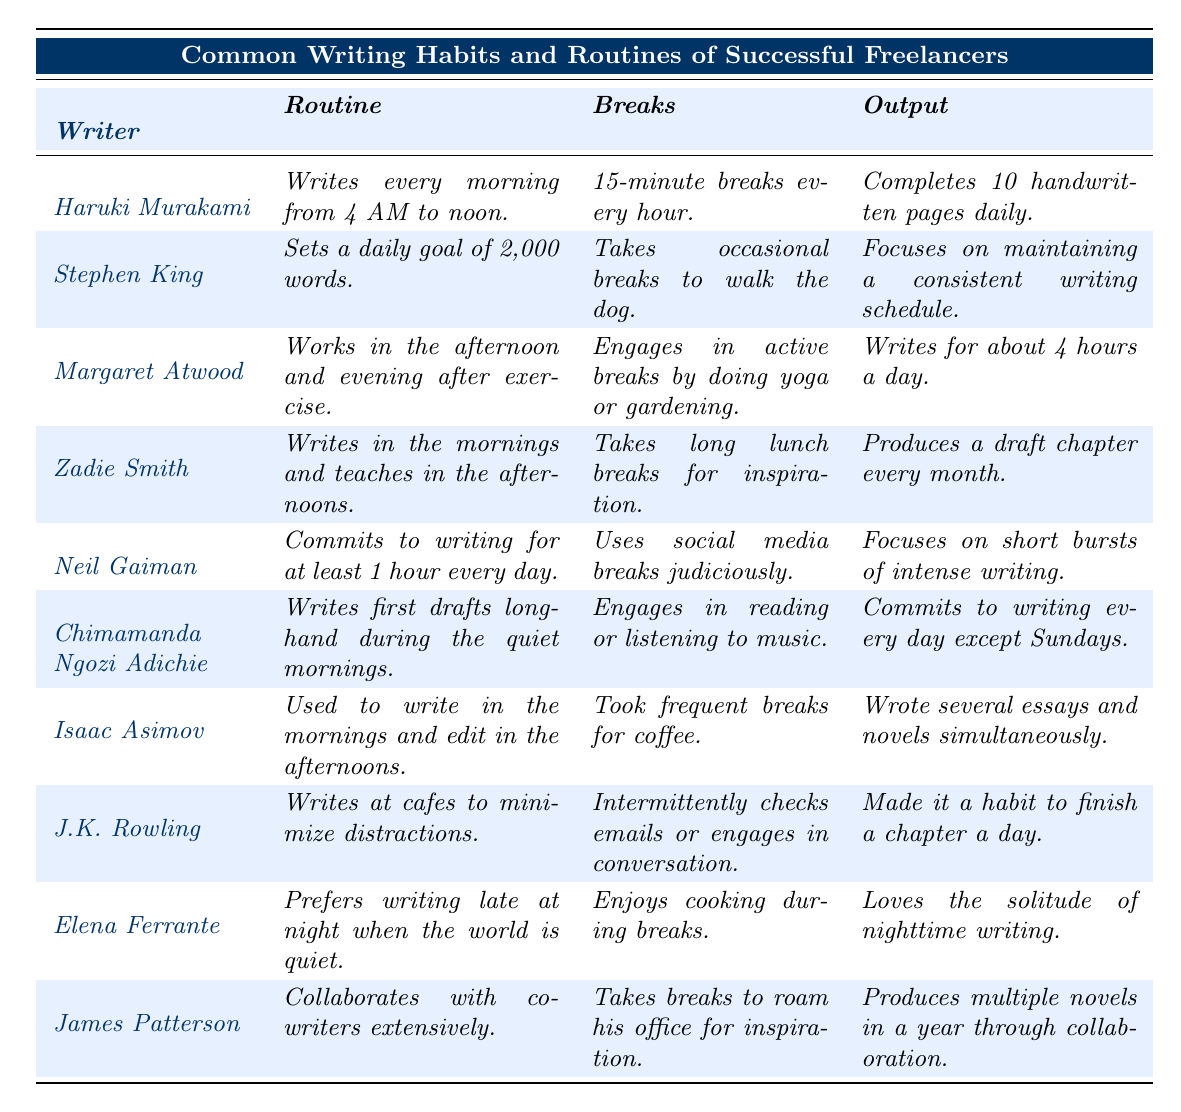What is the routine of Neil Gaiman? According to the table, Neil Gaiman commits to writing for at least 1 hour every day.
Answer: Writes for at least 1 hour daily How many handwritten pages does Haruki Murakami complete daily? The table states that Haruki Murakami completes 10 handwritten pages daily.
Answer: 10 pages Which writer engages in yoga or gardening during breaks? The table mentions that Margaret Atwood engages in active breaks by doing yoga or gardening.
Answer: Margaret Atwood What is the daily writing goal set by Stephen King? The table shows that Stephen King sets a daily goal of 2,000 words.
Answer: 2,000 words Does J.K. Rowling write at home? The table indicates that J.K. Rowling writes at cafes to minimize distractions, suggesting she does not typically write at home.
Answer: No How many hours does Margaret Atwood write on average per day? The table states that Margaret Atwood writes for about 4 hours a day.
Answer: About 4 hours Which writers prefer writing at specific times of the day? The table indicates that Haruki Murakami writes in the morning, Elena Ferrante writes late at night, and Zadie Smith writes in the mornings.
Answer: Haruki Murakami, Elena Ferrante, Zadie Smith Can you name a writer who incorporates breaks for cooking? The table states that Elena Ferrante enjoys cooking during breaks.
Answer: Elena Ferrante Which writer has a routine that involves collaboration? The table mentions that James Patterson collaborates with co-writers extensively.
Answer: James Patterson If we look at the output of each writer, who has the highest daily writing output? The highest daily output stated in the table is from Haruki Murakami, who completes 10 handwritten pages. Comparing others, his output is the most substantial.
Answer: Haruki Murakami What writing habits do both Neil Gaiman and Margaret Atwood have in common? Both writers emphasize consistency in their routines: Neil Gaiman writes at least an hour daily, while Margaret Atwood writes for about 4 hours a day. They both structure their writing routines around specific times.
Answer: Consistency in writing routines Which writer writes drafts longhand and also listens to music during breaks? The table indicates that Chimamanda Ngozi Adichie writes first drafts longhand and engages in reading or listening to music during breaks.
Answer: Chimamanda Ngozi Adichie Which writer has a writing routine that includes a specific word count? Stephen King has a routine that includes a specific writing goal of 2,000 words daily.
Answer: Stephen King 